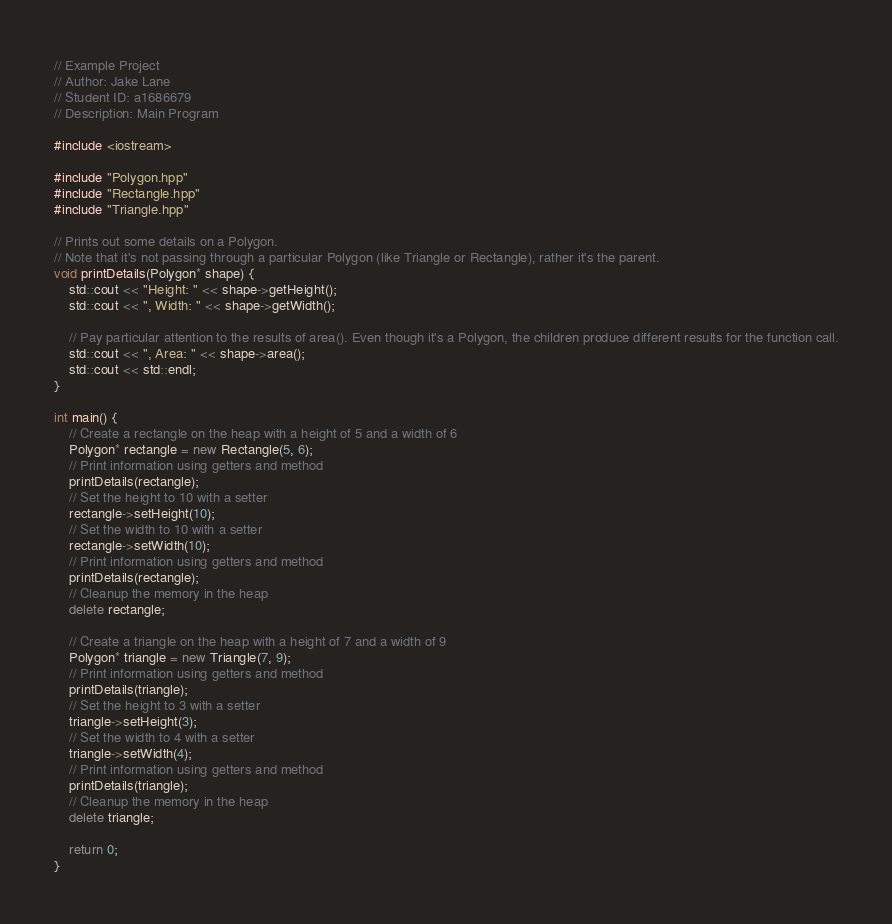Convert code to text. <code><loc_0><loc_0><loc_500><loc_500><_C++_>// Example Project
// Author: Jake Lane
// Student ID: a1686679
// Description: Main Program

#include <iostream>

#include "Polygon.hpp"
#include "Rectangle.hpp"
#include "Triangle.hpp"

// Prints out some details on a Polygon.
// Note that it's not passing through a particular Polygon (like Triangle or Rectangle), rather it's the parent.
void printDetails(Polygon* shape) {
	std::cout << "Height: " << shape->getHeight();
	std::cout << ", Width: " << shape->getWidth();

	// Pay particular attention to the results of area(). Even though it's a Polygon, the children produce different results for the function call.
	std::cout << ", Area: " << shape->area();
	std::cout << std::endl;
}

int main() {
	// Create a rectangle on the heap with a height of 5 and a width of 6
	Polygon* rectangle = new Rectangle(5, 6);
	// Print information using getters and method
	printDetails(rectangle);
	// Set the height to 10 with a setter
	rectangle->setHeight(10);
	// Set the width to 10 with a setter
	rectangle->setWidth(10);
	// Print information using getters and method
	printDetails(rectangle);
	// Cleanup the memory in the heap
	delete rectangle;

	// Create a triangle on the heap with a height of 7 and a width of 9
	Polygon* triangle = new Triangle(7, 9);
	// Print information using getters and method
	printDetails(triangle);
	// Set the height to 3 with a setter
	triangle->setHeight(3);
	// Set the width to 4 with a setter
	triangle->setWidth(4);
	// Print information using getters and method
	printDetails(triangle);
	// Cleanup the memory in the heap
	delete triangle;

	return 0;
}
</code> 